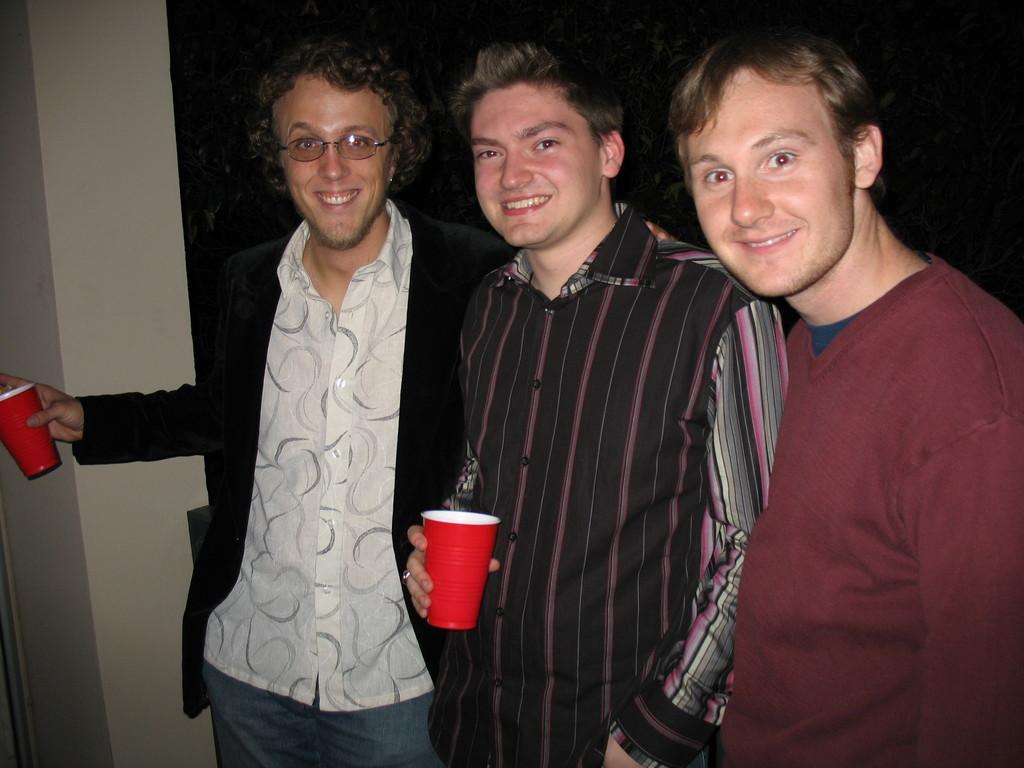Could you give a brief overview of what you see in this image? In this image I can see three people standing and posing for the picture. I can see two of them are holding glass in their hands and the background is dark. 